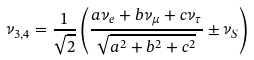Convert formula to latex. <formula><loc_0><loc_0><loc_500><loc_500>\nu _ { 3 , 4 } = \frac { 1 } { \sqrt { 2 } } \left ( \frac { a \nu _ { e } + b \nu _ { \mu } + c \nu _ { \tau } } { \sqrt { a ^ { 2 } + b ^ { 2 } + c ^ { 2 } } } \pm \nu _ { S } \right )</formula> 